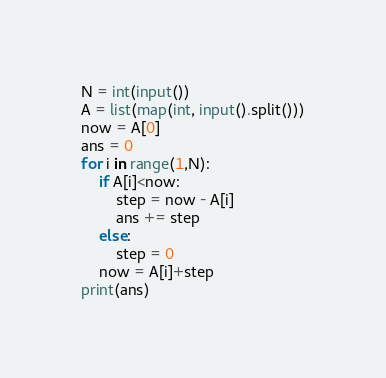<code> <loc_0><loc_0><loc_500><loc_500><_Python_>N = int(input())
A = list(map(int, input().split()))
now = A[0]
ans = 0
for i in range(1,N):
    if A[i]<now:
        step = now - A[i]
        ans += step
    else:
        step = 0
    now = A[i]+step
print(ans)
</code> 